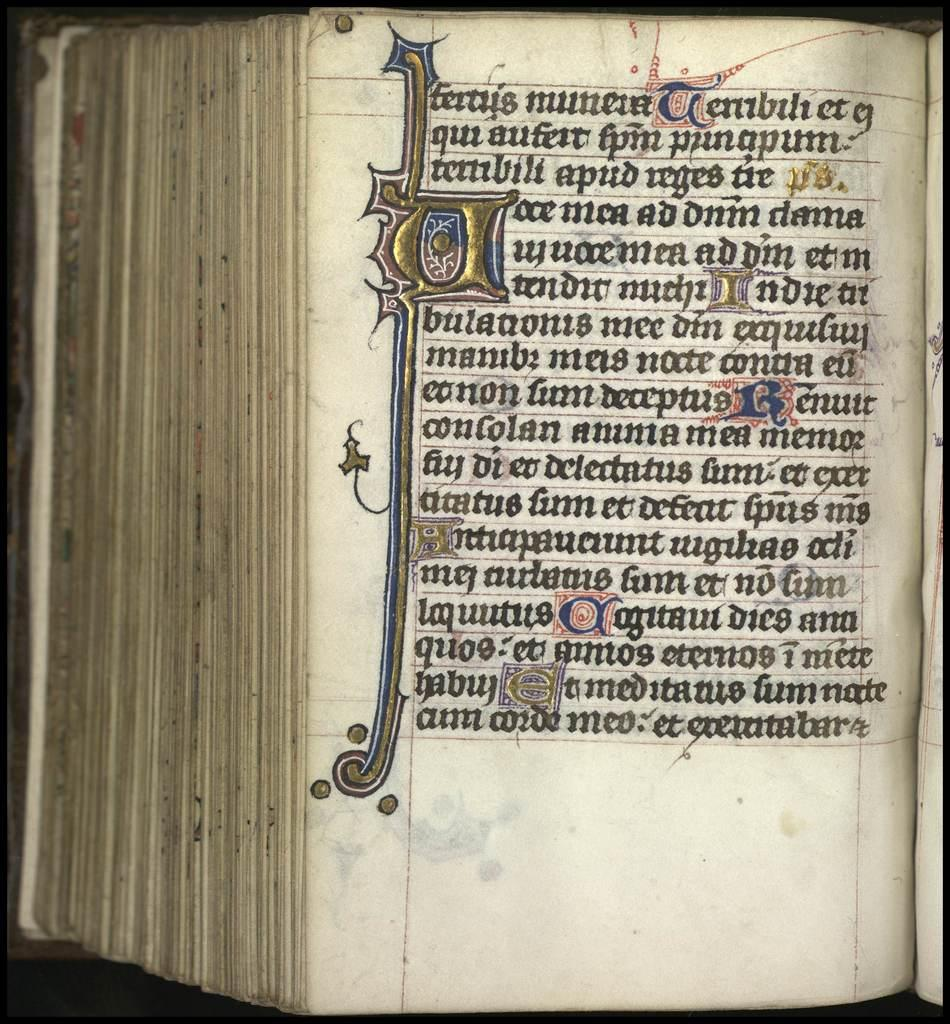<image>
Provide a brief description of the given image. the rare book which has a traditional style of English writings with the attractive designed letter P in the left side. 